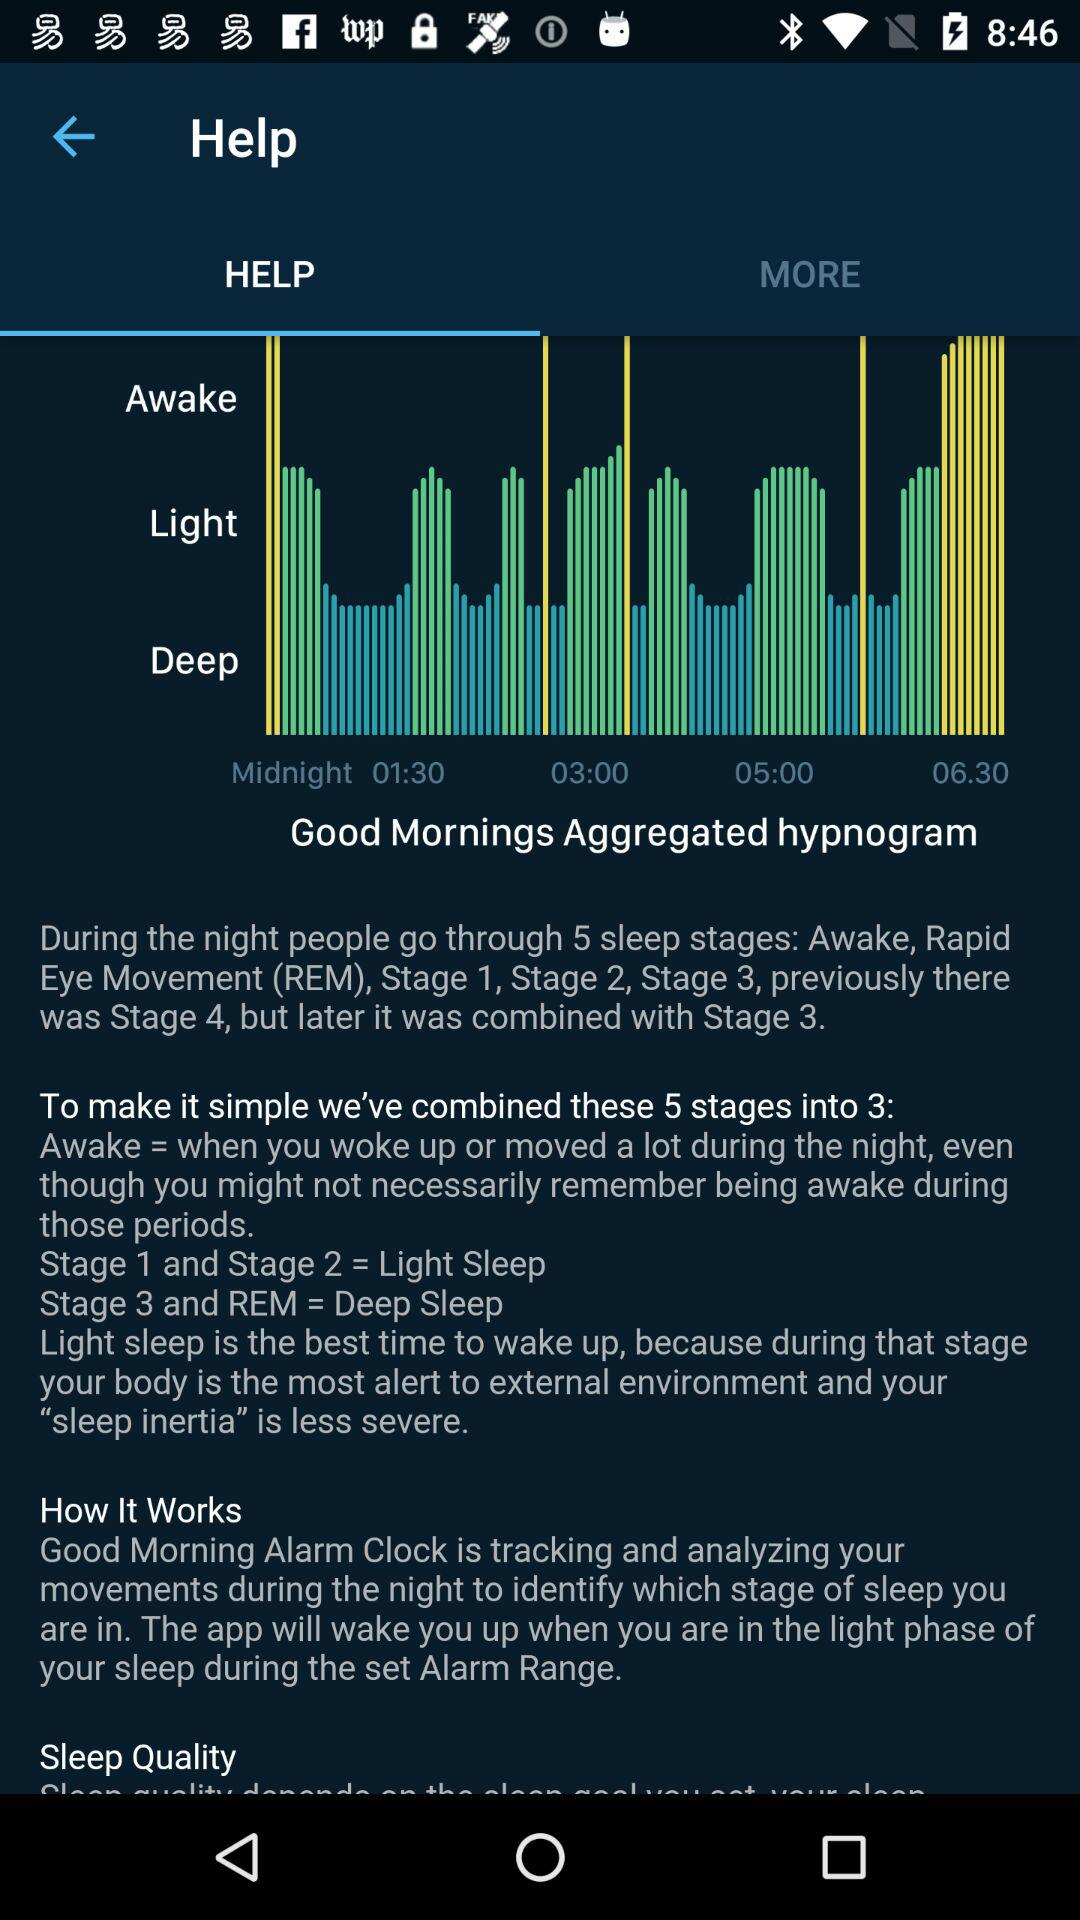How many sleep stages do people go through during the night? People go through five sleep stages during the night. 